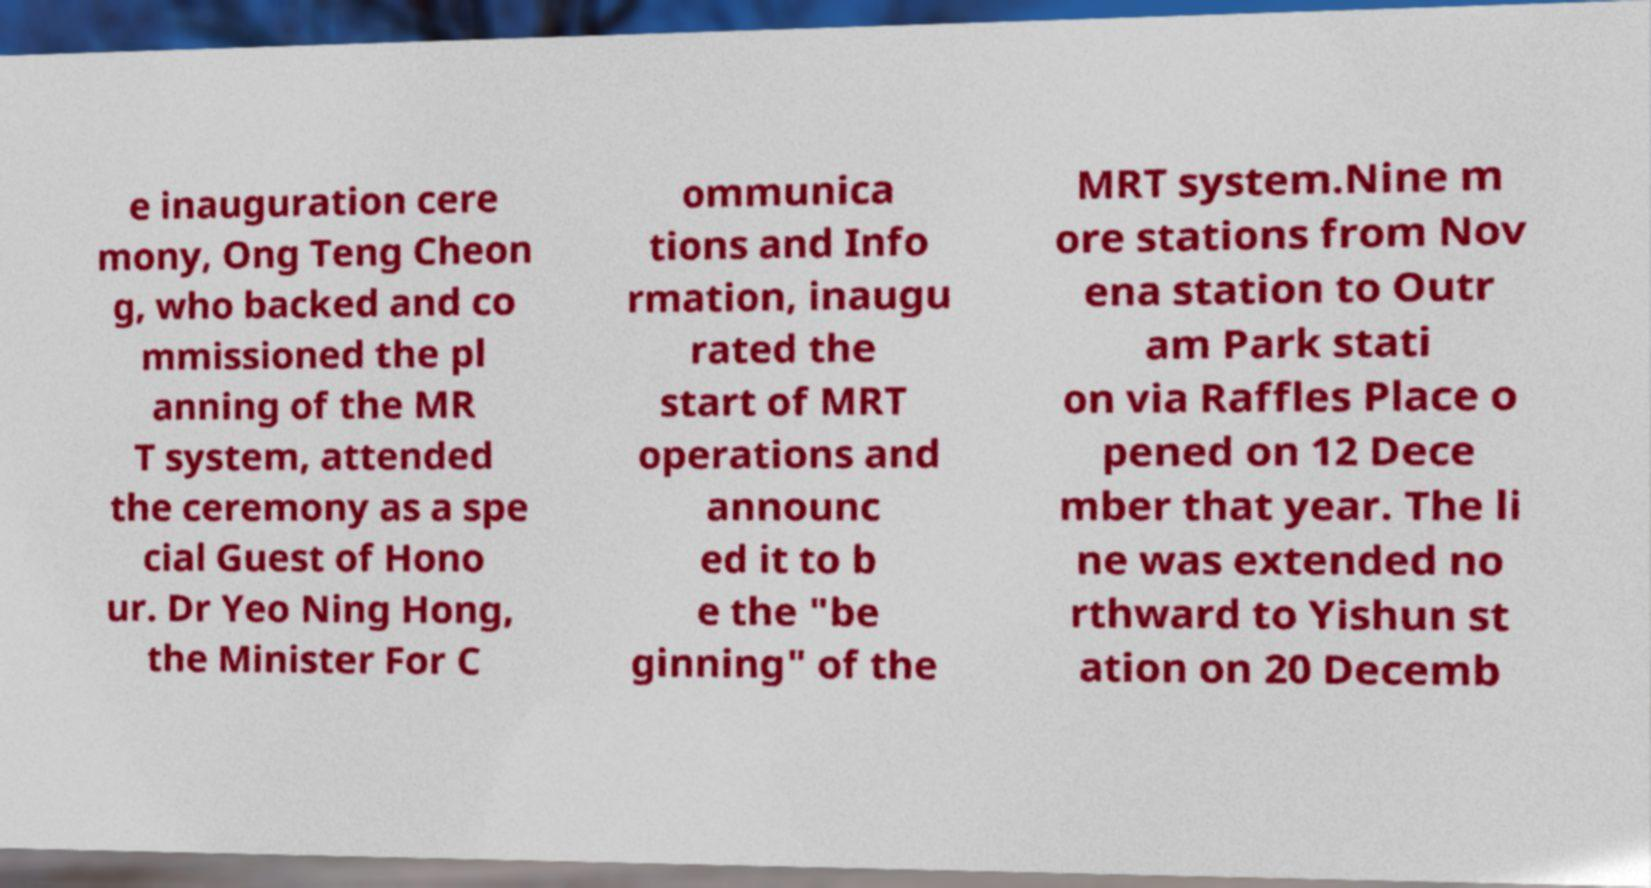What messages or text are displayed in this image? I need them in a readable, typed format. e inauguration cere mony, Ong Teng Cheon g, who backed and co mmissioned the pl anning of the MR T system, attended the ceremony as a spe cial Guest of Hono ur. Dr Yeo Ning Hong, the Minister For C ommunica tions and Info rmation, inaugu rated the start of MRT operations and announc ed it to b e the "be ginning" of the MRT system.Nine m ore stations from Nov ena station to Outr am Park stati on via Raffles Place o pened on 12 Dece mber that year. The li ne was extended no rthward to Yishun st ation on 20 Decemb 